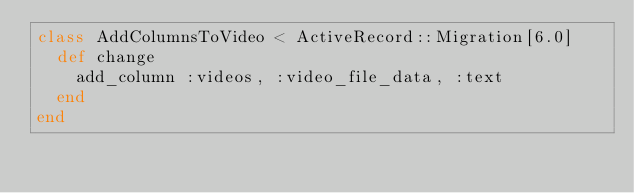Convert code to text. <code><loc_0><loc_0><loc_500><loc_500><_Ruby_>class AddColumnsToVideo < ActiveRecord::Migration[6.0]
  def change
    add_column :videos, :video_file_data, :text
  end
end
</code> 